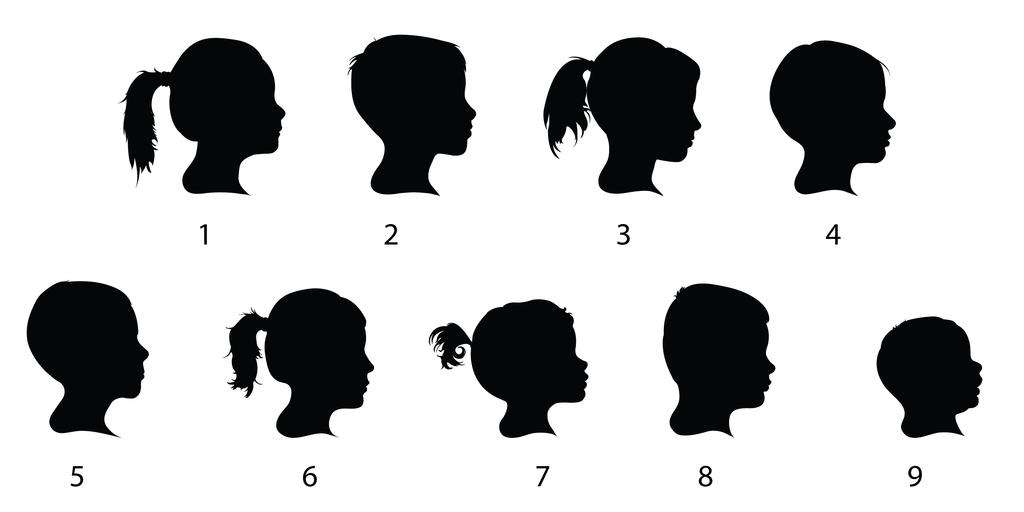What type of images are present in the picture? There are silhouette images of human beings in the picture. What hobbies do the people in the silhouette images have? There is no information about the hobbies of the people in the silhouette images, as the image only provides visual information about their silhouettes. 